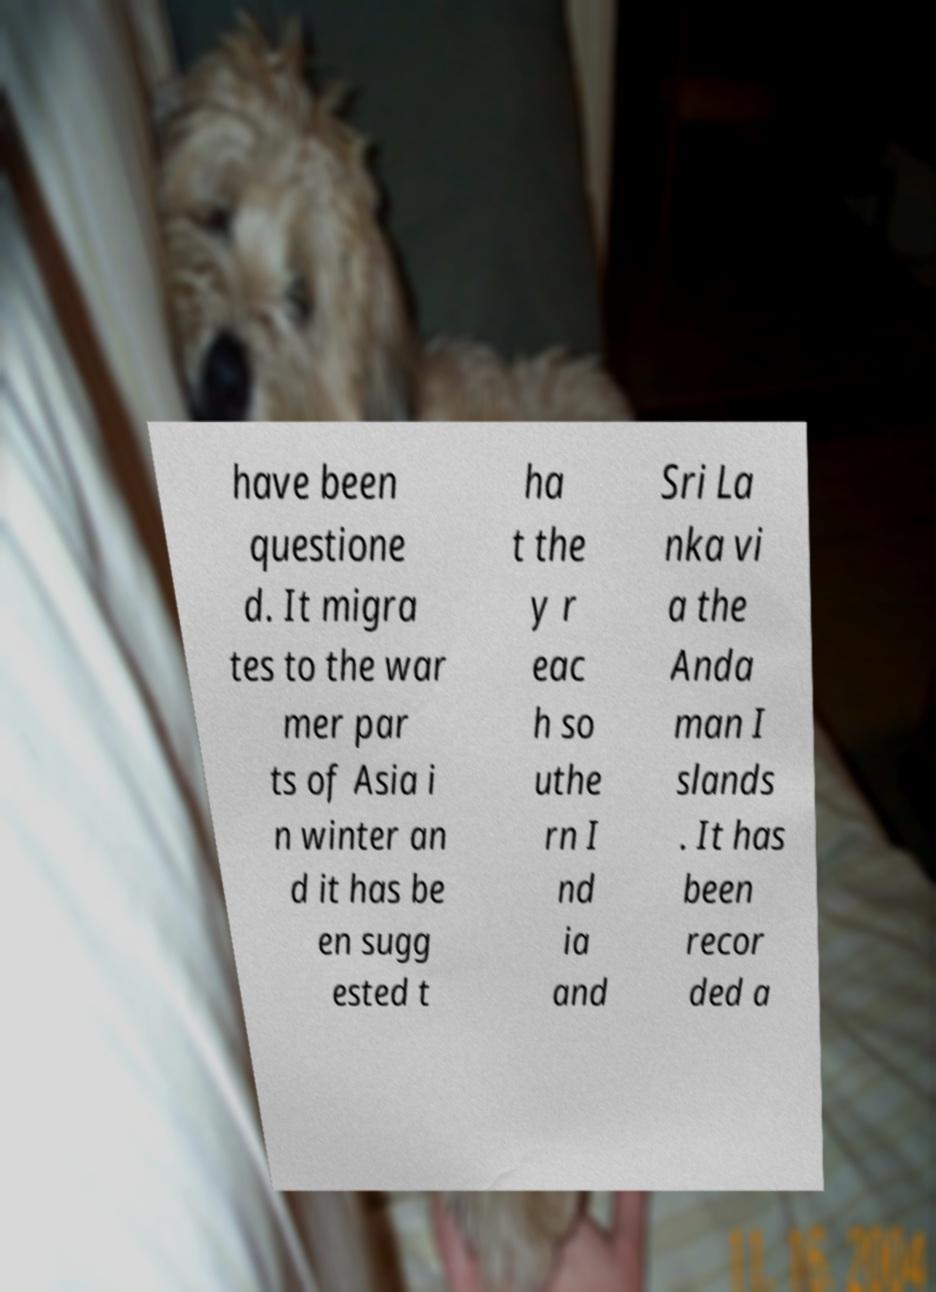Can you read and provide the text displayed in the image?This photo seems to have some interesting text. Can you extract and type it out for me? have been questione d. It migra tes to the war mer par ts of Asia i n winter an d it has be en sugg ested t ha t the y r eac h so uthe rn I nd ia and Sri La nka vi a the Anda man I slands . It has been recor ded a 